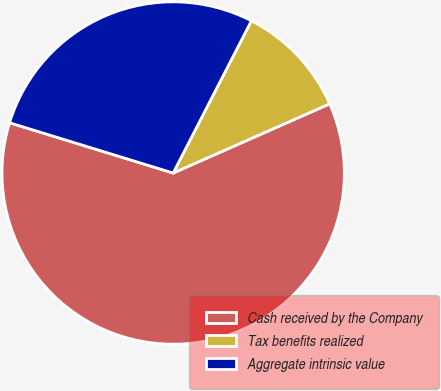Convert chart to OTSL. <chart><loc_0><loc_0><loc_500><loc_500><pie_chart><fcel>Cash received by the Company<fcel>Tax benefits realized<fcel>Aggregate intrinsic value<nl><fcel>61.37%<fcel>10.82%<fcel>27.81%<nl></chart> 